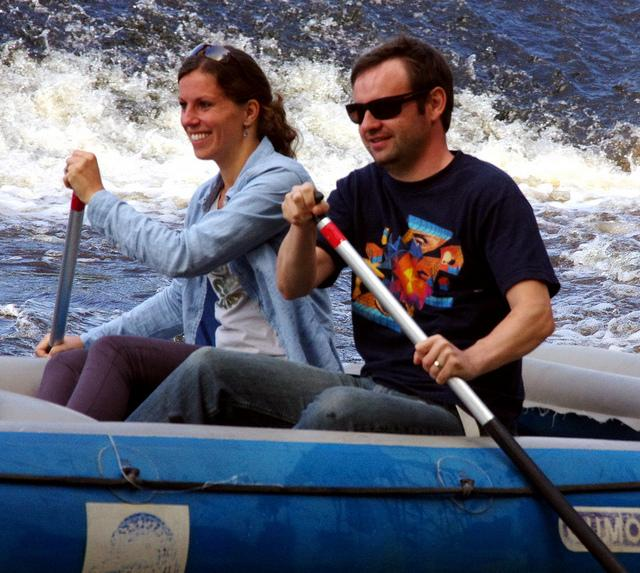What should they have worn before starting the activity? life jacket 